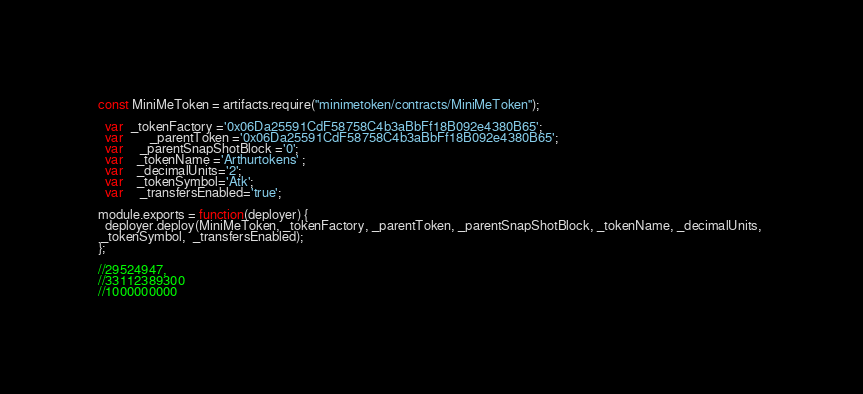Convert code to text. <code><loc_0><loc_0><loc_500><loc_500><_JavaScript_>const MiniMeToken = artifacts.require("minimetoken/contracts/MiniMeToken");

  var  _tokenFactory ='0x06Da25591CdF58758C4b3aBbFf18B092e4380B65';
  var        _parentToken ='0x06Da25591CdF58758C4b3aBbFf18B092e4380B65';
  var     _parentSnapShotBlock ='0';
  var    _tokenName ='Arthurtokens' ;
  var    _decimalUnits='2';
  var    _tokenSymbol='Atk';
  var     _transfersEnabled='true';

module.exports = function(deployer) {
  deployer.deploy(MiniMeToken, _tokenFactory, _parentToken, _parentSnapShotBlock, _tokenName, _decimalUnits, 
 _tokenSymbol,  _transfersEnabled);
};

//29524947,
//33112389300
//1000000000</code> 